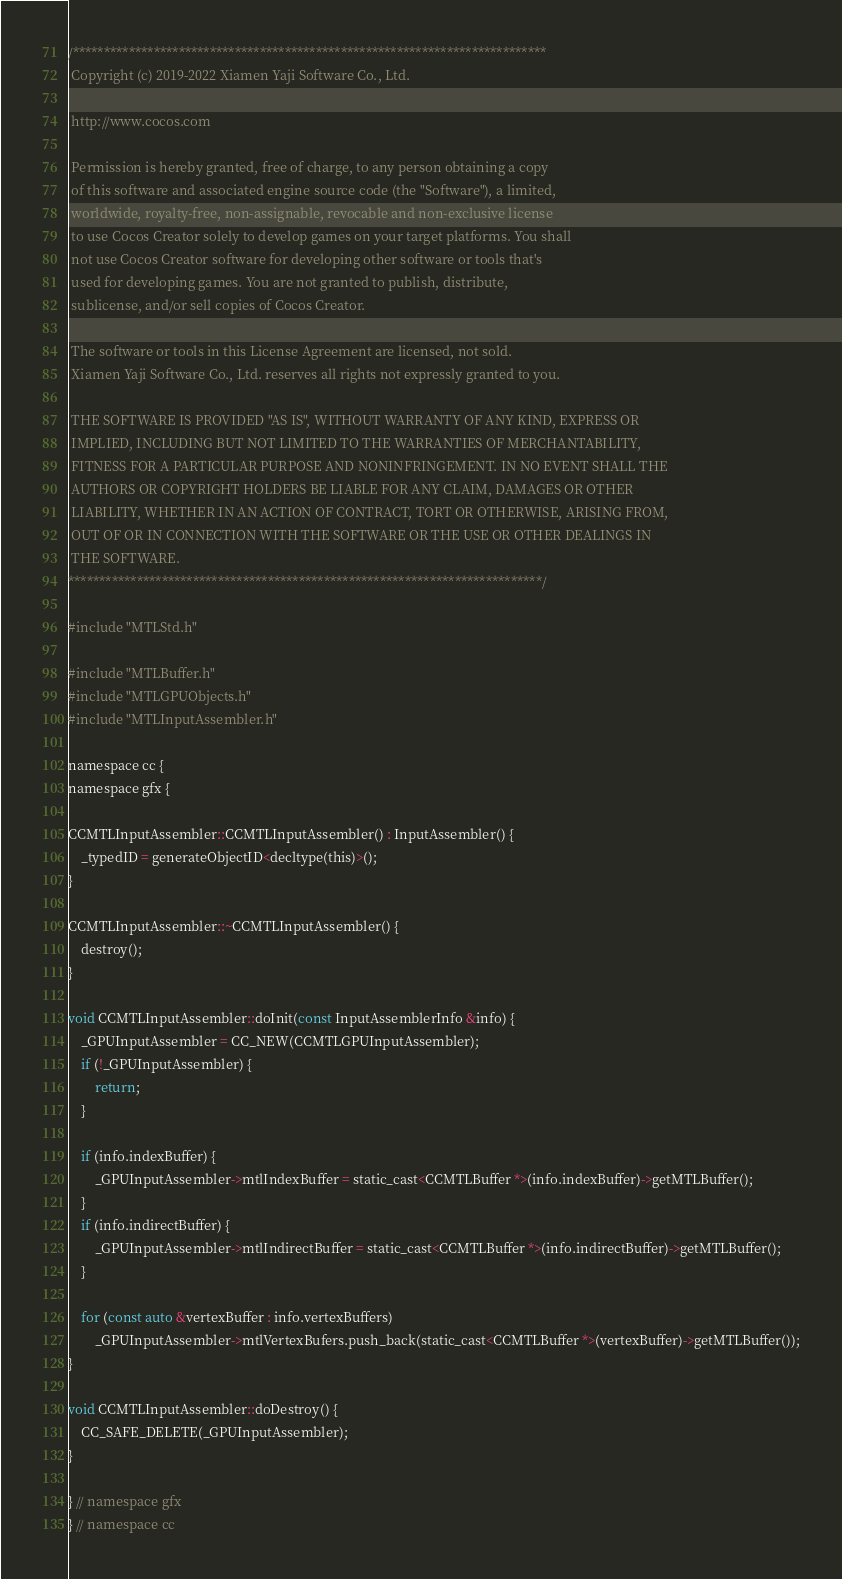Convert code to text. <code><loc_0><loc_0><loc_500><loc_500><_ObjectiveC_>/****************************************************************************
 Copyright (c) 2019-2022 Xiamen Yaji Software Co., Ltd.

 http://www.cocos.com

 Permission is hereby granted, free of charge, to any person obtaining a copy
 of this software and associated engine source code (the "Software"), a limited,
 worldwide, royalty-free, non-assignable, revocable and non-exclusive license
 to use Cocos Creator solely to develop games on your target platforms. You shall
 not use Cocos Creator software for developing other software or tools that's
 used for developing games. You are not granted to publish, distribute,
 sublicense, and/or sell copies of Cocos Creator.

 The software or tools in this License Agreement are licensed, not sold.
 Xiamen Yaji Software Co., Ltd. reserves all rights not expressly granted to you.

 THE SOFTWARE IS PROVIDED "AS IS", WITHOUT WARRANTY OF ANY KIND, EXPRESS OR
 IMPLIED, INCLUDING BUT NOT LIMITED TO THE WARRANTIES OF MERCHANTABILITY,
 FITNESS FOR A PARTICULAR PURPOSE AND NONINFRINGEMENT. IN NO EVENT SHALL THE
 AUTHORS OR COPYRIGHT HOLDERS BE LIABLE FOR ANY CLAIM, DAMAGES OR OTHER
 LIABILITY, WHETHER IN AN ACTION OF CONTRACT, TORT OR OTHERWISE, ARISING FROM,
 OUT OF OR IN CONNECTION WITH THE SOFTWARE OR THE USE OR OTHER DEALINGS IN
 THE SOFTWARE.
****************************************************************************/

#include "MTLStd.h"

#include "MTLBuffer.h"
#include "MTLGPUObjects.h"
#include "MTLInputAssembler.h"

namespace cc {
namespace gfx {

CCMTLInputAssembler::CCMTLInputAssembler() : InputAssembler() {
    _typedID = generateObjectID<decltype(this)>();
}

CCMTLInputAssembler::~CCMTLInputAssembler() {
    destroy();
}

void CCMTLInputAssembler::doInit(const InputAssemblerInfo &info) {
    _GPUInputAssembler = CC_NEW(CCMTLGPUInputAssembler);
    if (!_GPUInputAssembler) {
        return;
    }

    if (info.indexBuffer) {
        _GPUInputAssembler->mtlIndexBuffer = static_cast<CCMTLBuffer *>(info.indexBuffer)->getMTLBuffer();
    }
    if (info.indirectBuffer) {
        _GPUInputAssembler->mtlIndirectBuffer = static_cast<CCMTLBuffer *>(info.indirectBuffer)->getMTLBuffer();
    }

    for (const auto &vertexBuffer : info.vertexBuffers)
        _GPUInputAssembler->mtlVertexBufers.push_back(static_cast<CCMTLBuffer *>(vertexBuffer)->getMTLBuffer());
}

void CCMTLInputAssembler::doDestroy() {
    CC_SAFE_DELETE(_GPUInputAssembler);
}

} // namespace gfx
} // namespace cc
</code> 